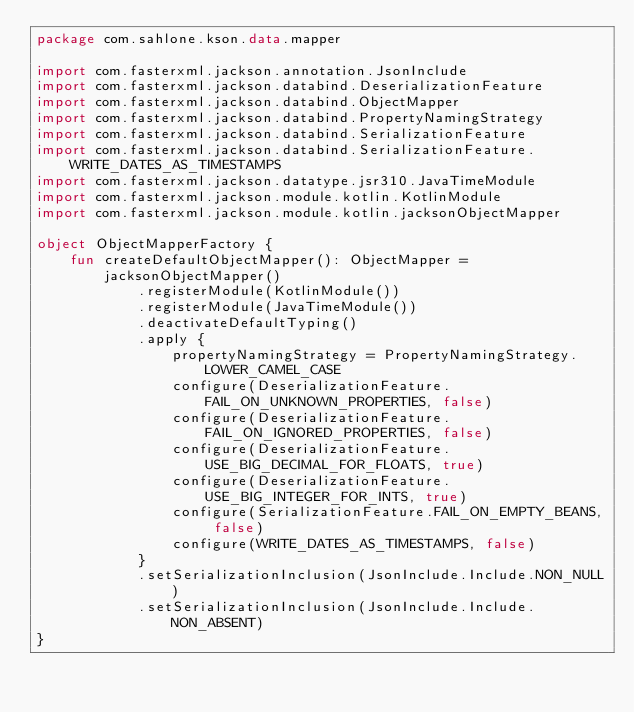Convert code to text. <code><loc_0><loc_0><loc_500><loc_500><_Kotlin_>package com.sahlone.kson.data.mapper

import com.fasterxml.jackson.annotation.JsonInclude
import com.fasterxml.jackson.databind.DeserializationFeature
import com.fasterxml.jackson.databind.ObjectMapper
import com.fasterxml.jackson.databind.PropertyNamingStrategy
import com.fasterxml.jackson.databind.SerializationFeature
import com.fasterxml.jackson.databind.SerializationFeature.WRITE_DATES_AS_TIMESTAMPS
import com.fasterxml.jackson.datatype.jsr310.JavaTimeModule
import com.fasterxml.jackson.module.kotlin.KotlinModule
import com.fasterxml.jackson.module.kotlin.jacksonObjectMapper

object ObjectMapperFactory {
    fun createDefaultObjectMapper(): ObjectMapper =
        jacksonObjectMapper()
            .registerModule(KotlinModule())
            .registerModule(JavaTimeModule())
            .deactivateDefaultTyping()
            .apply {
                propertyNamingStrategy = PropertyNamingStrategy.LOWER_CAMEL_CASE
                configure(DeserializationFeature.FAIL_ON_UNKNOWN_PROPERTIES, false)
                configure(DeserializationFeature.FAIL_ON_IGNORED_PROPERTIES, false)
                configure(DeserializationFeature.USE_BIG_DECIMAL_FOR_FLOATS, true)
                configure(DeserializationFeature.USE_BIG_INTEGER_FOR_INTS, true)
                configure(SerializationFeature.FAIL_ON_EMPTY_BEANS, false)
                configure(WRITE_DATES_AS_TIMESTAMPS, false)
            }
            .setSerializationInclusion(JsonInclude.Include.NON_NULL)
            .setSerializationInclusion(JsonInclude.Include.NON_ABSENT)
}
</code> 